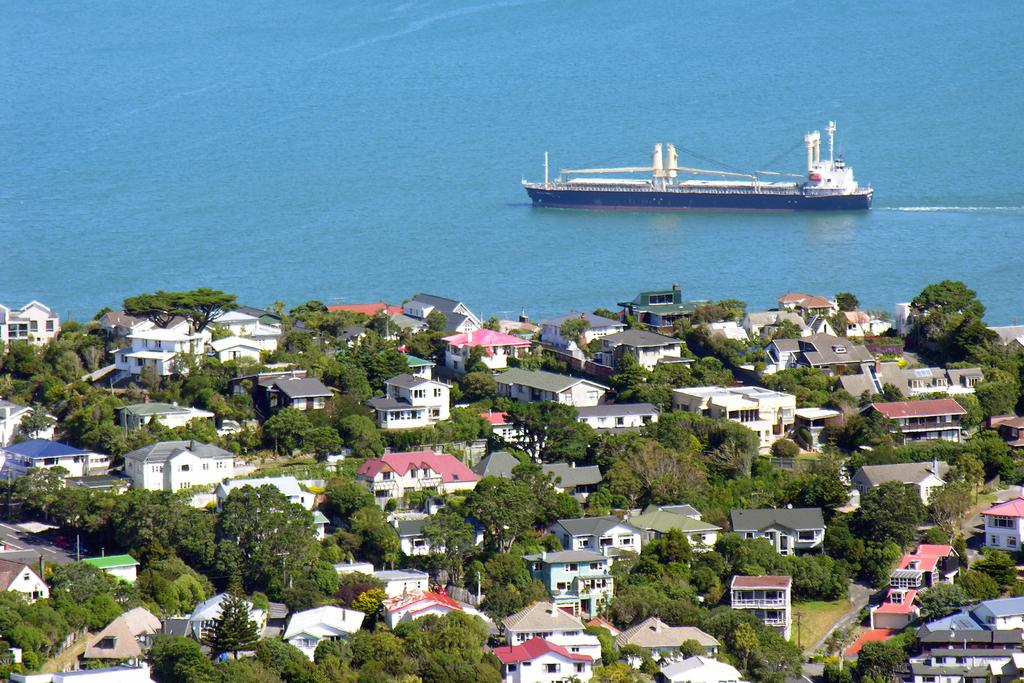What types of structures are located at the bottom of the image? There are houses and buildings at the bottom of the image. What else can be seen at the bottom of the image? There are trees and poles at the bottom of the image. What is located at the top of the image? There is a river at the top of the image. What is in the river? There is a ship in the river. How many ants are crawling on the ship in the image? There are no ants present in the image, and therefore no such activity can be observed. What types of pets can be seen in the houses at the bottom of the image? There is no information about pets in the image; it only shows houses, buildings, trees, poles, a river, and a ship. 